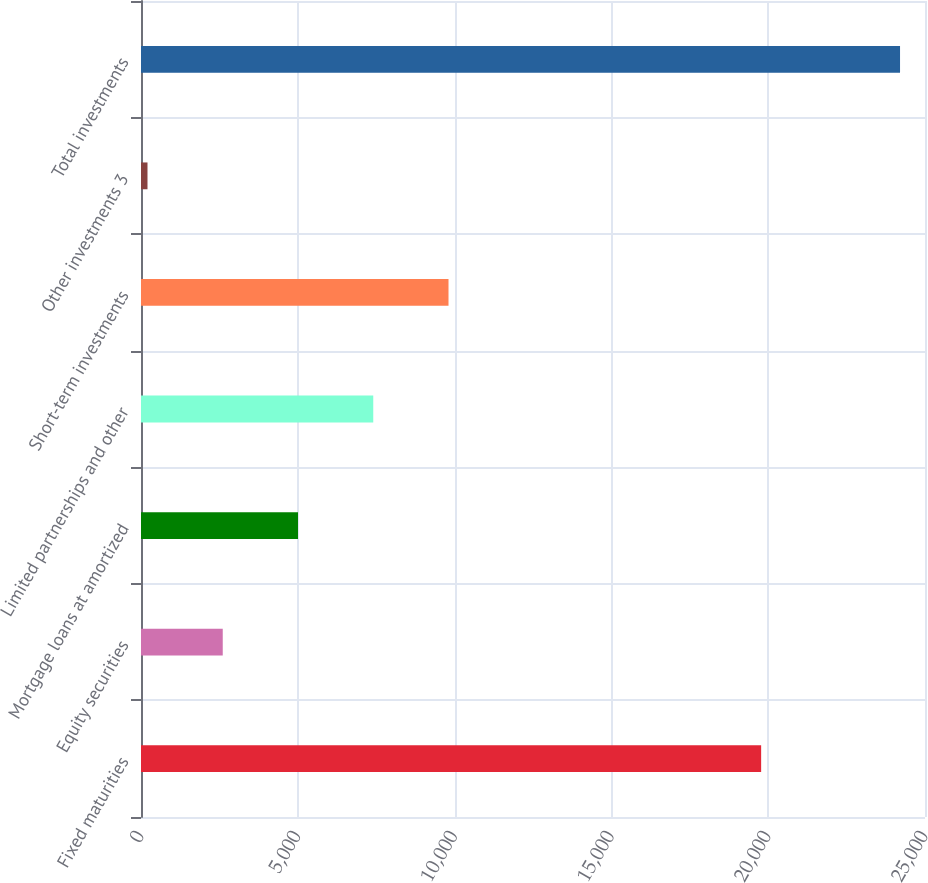Convert chart to OTSL. <chart><loc_0><loc_0><loc_500><loc_500><bar_chart><fcel>Fixed maturities<fcel>Equity securities<fcel>Mortgage loans at amortized<fcel>Limited partnerships and other<fcel>Short-term investments<fcel>Other investments 3<fcel>Total investments<nl><fcel>19775<fcel>2606.7<fcel>5006.4<fcel>7406.1<fcel>9805.8<fcel>207<fcel>24204<nl></chart> 